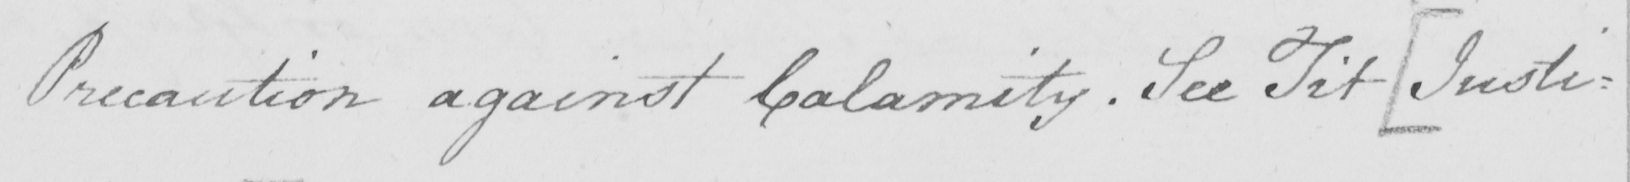Please transcribe the handwritten text in this image. Precaution against Calamity . See Tit .  [ Justi= 